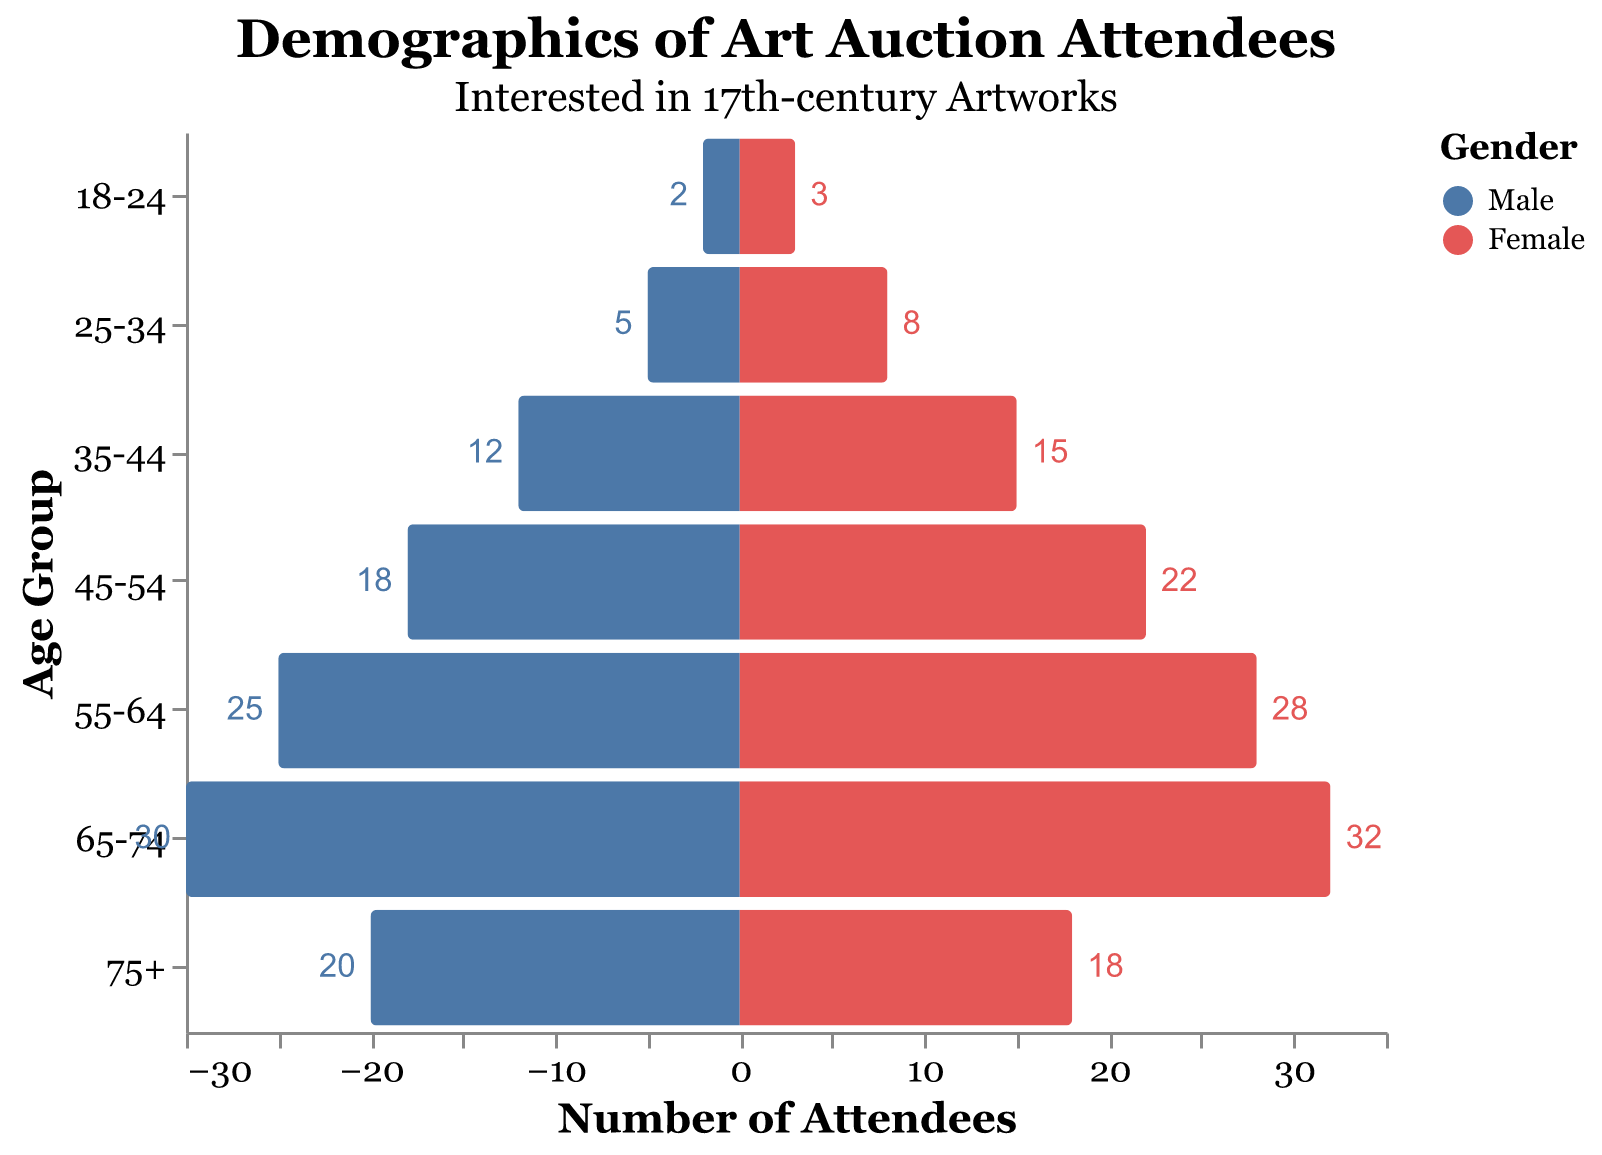What is the title of the figure? The title is displayed at the top of the figure. It reads "Demographics of Art Auction Attendees," and the subtitle is "Interested in 17th-century Artworks."
Answer: Demographics of Art Auction Attendees How many age groups are represented in the figure? Look at the Y-axis which lists the age groups. There are seven age groups in total: "18-24", "25-34", "35-44", "45-54", "55-64", "65-74", and "75+."
Answer: 7 In which age group is the number of female attendees the highest? By examining the bars on the right side of the figure (representing females), the age group "65-74" has the longest bar for females, indicating the highest number.
Answer: 65-74 What is the total number of male attendees across all age groups? Sum the numbers of male attendees in each age group: 2 + 5 + 12 + 18 + 25 + 30 + 20 = 112
Answer: 112 How many more female attendees are there than male attendees in the 45-54 age group? Subtract the number of male attendees from the number of female attendees for the 45-54 age group: 22 - 18 = 4
Answer: 4 What is the ratio of male to female attendees in the 25-34 age group? Divide the number of male attendees by the number of female attendees for the 25-34 age group: 5/8 = 0.625
Answer: 0.625 Which gender has a higher overall representation in the age group 75+? Compare the lengths of the bars for males and females in the 75+ age group. The bar representing male attendees is longer, indicating higher representation.
Answer: Male What's the average number of attendees (both male and female) in the 55-64 age group? Add the number of male and female attendees in the 55-64 age group, then divide by 2: (25 + 28) / 2 = 26.5
Answer: 26.5 In which age group is the gender representation approximately equal? Compare the bars for males and females in each age group. In the 75+ age group, the numbers are close: 20 males and 18 females, making it the most equal representation.
Answer: 75+ 